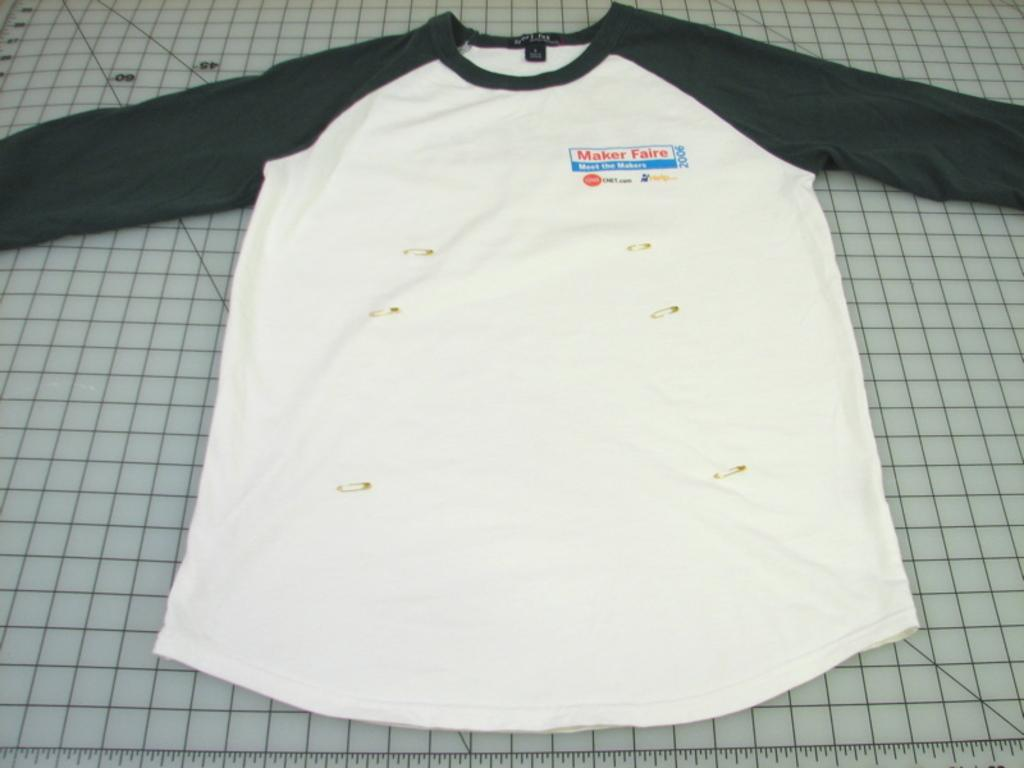What type of clothing item is in the image? There is a T-shirt in the image. Where is the T-shirt placed? The T-shirt is placed on a cutting mat. What is the purpose of the scale at the bottom of the image? The purpose of the scale is not explicitly stated in the facts, but it could be used for measuring or weighing the T-shirt or other items. How many credits are required to purchase the T-shirt in the image? There is no information about credits or purchasing in the image, so it cannot be determined. What type of kite is depicted in the image? There is no kite present in the image. 